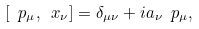<formula> <loc_0><loc_0><loc_500><loc_500>[ \ p _ { \mu } , \ x _ { \nu } ] = \delta _ { \mu \nu } + i a _ { \nu } \ p _ { \mu } ,</formula> 